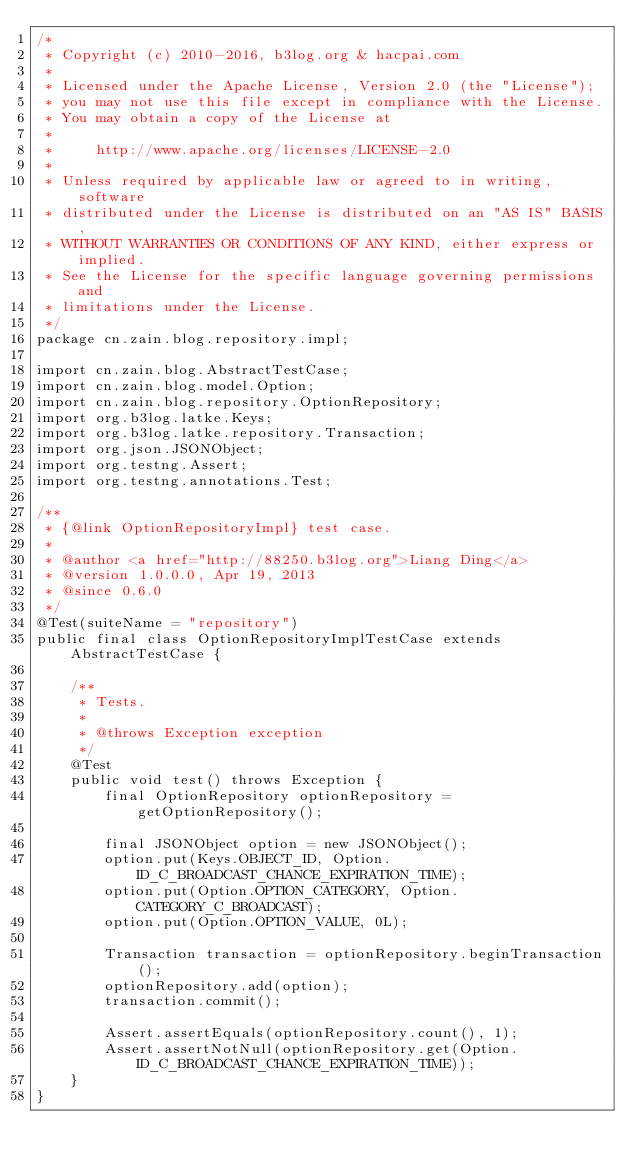<code> <loc_0><loc_0><loc_500><loc_500><_Java_>/*
 * Copyright (c) 2010-2016, b3log.org & hacpai.com
 *
 * Licensed under the Apache License, Version 2.0 (the "License");
 * you may not use this file except in compliance with the License.
 * You may obtain a copy of the License at
 *
 *     http://www.apache.org/licenses/LICENSE-2.0
 *
 * Unless required by applicable law or agreed to in writing, software
 * distributed under the License is distributed on an "AS IS" BASIS,
 * WITHOUT WARRANTIES OR CONDITIONS OF ANY KIND, either express or implied.
 * See the License for the specific language governing permissions and
 * limitations under the License.
 */
package cn.zain.blog.repository.impl;

import cn.zain.blog.AbstractTestCase;
import cn.zain.blog.model.Option;
import cn.zain.blog.repository.OptionRepository;
import org.b3log.latke.Keys;
import org.b3log.latke.repository.Transaction;
import org.json.JSONObject;
import org.testng.Assert;
import org.testng.annotations.Test;

/**
 * {@link OptionRepositoryImpl} test case.
 *
 * @author <a href="http://88250.b3log.org">Liang Ding</a>
 * @version 1.0.0.0, Apr 19, 2013
 * @since 0.6.0
 */
@Test(suiteName = "repository")
public final class OptionRepositoryImplTestCase extends AbstractTestCase {

    /**
     * Tests.
     * 
     * @throws Exception exception
     */
    @Test
    public void test() throws Exception {
        final OptionRepository optionRepository = getOptionRepository();

        final JSONObject option = new JSONObject();
        option.put(Keys.OBJECT_ID, Option.ID_C_BROADCAST_CHANCE_EXPIRATION_TIME);
        option.put(Option.OPTION_CATEGORY, Option.CATEGORY_C_BROADCAST);
        option.put(Option.OPTION_VALUE, 0L);

        Transaction transaction = optionRepository.beginTransaction();
        optionRepository.add(option);
        transaction.commit();

        Assert.assertEquals(optionRepository.count(), 1);
        Assert.assertNotNull(optionRepository.get(Option.ID_C_BROADCAST_CHANCE_EXPIRATION_TIME));
    }
}
</code> 